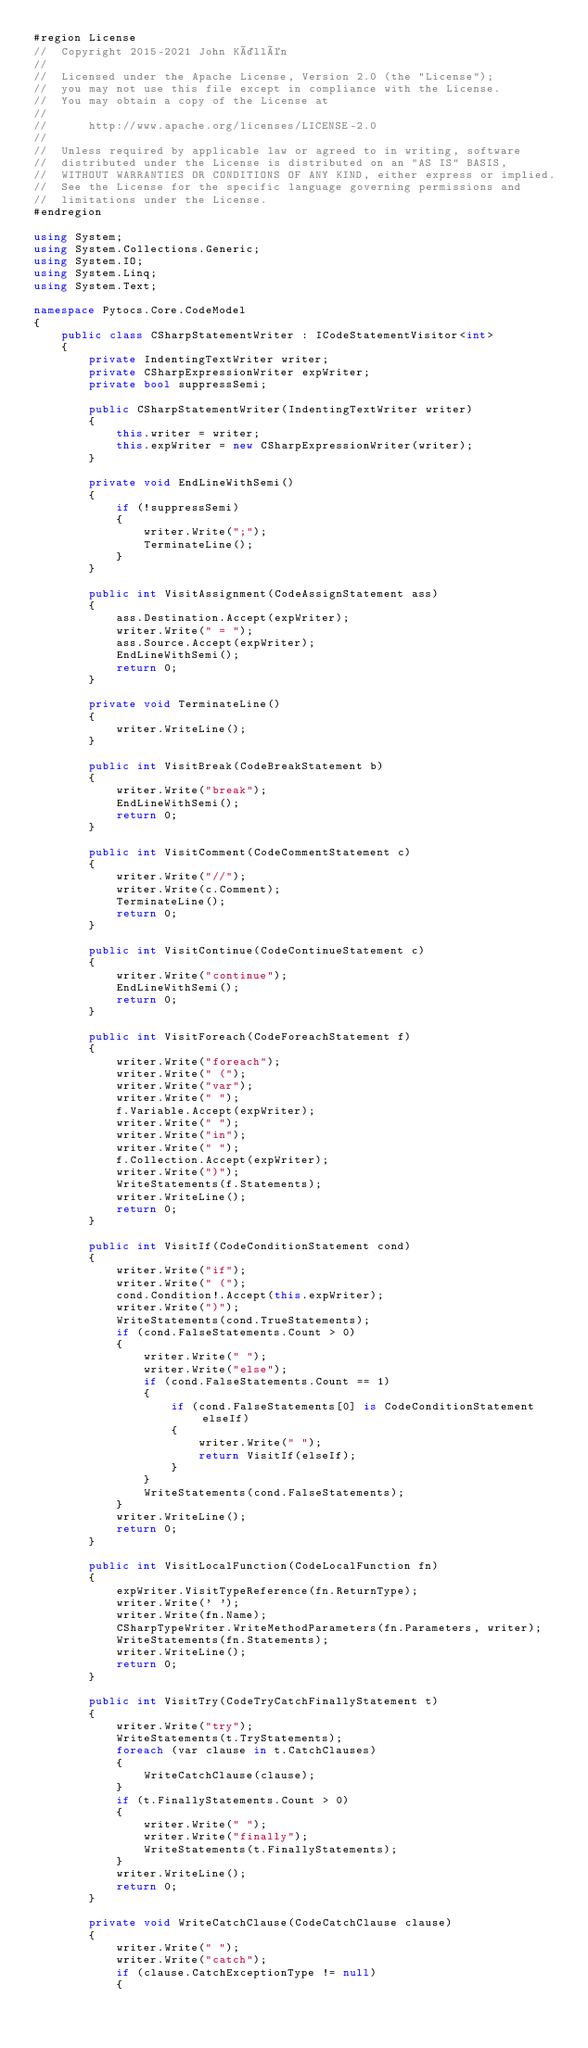Convert code to text. <code><loc_0><loc_0><loc_500><loc_500><_C#_>#region License
//  Copyright 2015-2021 John Källén
// 
//  Licensed under the Apache License, Version 2.0 (the "License");
//  you may not use this file except in compliance with the License.
//  You may obtain a copy of the License at
// 
//      http://www.apache.org/licenses/LICENSE-2.0
// 
//  Unless required by applicable law or agreed to in writing, software
//  distributed under the License is distributed on an "AS IS" BASIS,
//  WITHOUT WARRANTIES OR CONDITIONS OF ANY KIND, either express or implied.
//  See the License for the specific language governing permissions and
//  limitations under the License.
#endregion

using System;
using System.Collections.Generic;
using System.IO;
using System.Linq;
using System.Text;

namespace Pytocs.Core.CodeModel
{
    public class CSharpStatementWriter : ICodeStatementVisitor<int>
    {
        private IndentingTextWriter writer;
        private CSharpExpressionWriter expWriter;
        private bool suppressSemi;

        public CSharpStatementWriter(IndentingTextWriter writer)
        {
            this.writer = writer;
            this.expWriter = new CSharpExpressionWriter(writer);
        }

        private void EndLineWithSemi()
        {
            if (!suppressSemi)
            {
                writer.Write(";");
                TerminateLine();
            }
        }

        public int VisitAssignment(CodeAssignStatement ass)
        {
            ass.Destination.Accept(expWriter);
            writer.Write(" = ");
            ass.Source.Accept(expWriter);
            EndLineWithSemi();
            return 0;
        }

        private void TerminateLine()
        {
            writer.WriteLine();
        }

        public int VisitBreak(CodeBreakStatement b)
        {
            writer.Write("break");
            EndLineWithSemi();
            return 0;
        }

        public int VisitComment(CodeCommentStatement c)
        {
            writer.Write("//");
            writer.Write(c.Comment);
            TerminateLine();
            return 0;
        }

        public int VisitContinue(CodeContinueStatement c)
        {
            writer.Write("continue");
            EndLineWithSemi();
            return 0;
        }

        public int VisitForeach(CodeForeachStatement f)
        {
            writer.Write("foreach");
            writer.Write(" (");
            writer.Write("var");
            writer.Write(" ");
            f.Variable.Accept(expWriter);
            writer.Write(" ");
            writer.Write("in");
            writer.Write(" ");
            f.Collection.Accept(expWriter);
            writer.Write(")");
            WriteStatements(f.Statements);
            writer.WriteLine();
            return 0;
        }

        public int VisitIf(CodeConditionStatement cond)
        {
            writer.Write("if");
            writer.Write(" (");
            cond.Condition!.Accept(this.expWriter);
            writer.Write(")");
            WriteStatements(cond.TrueStatements);
            if (cond.FalseStatements.Count > 0)
            {
                writer.Write(" ");
                writer.Write("else");
                if (cond.FalseStatements.Count == 1)
                {
                    if (cond.FalseStatements[0] is CodeConditionStatement elseIf)
                    {
                        writer.Write(" ");
                        return VisitIf(elseIf);
                    }
                }
                WriteStatements(cond.FalseStatements);
            }
            writer.WriteLine();
            return 0;
        }

        public int VisitLocalFunction(CodeLocalFunction fn)
        { 
            expWriter.VisitTypeReference(fn.ReturnType);
            writer.Write(' ');
            writer.Write(fn.Name);
            CSharpTypeWriter.WriteMethodParameters(fn.Parameters, writer);
            WriteStatements(fn.Statements);
            writer.WriteLine();
            return 0;
        }

        public int VisitTry(CodeTryCatchFinallyStatement t)
        {
            writer.Write("try");
            WriteStatements(t.TryStatements);
            foreach (var clause in t.CatchClauses)
            {
                WriteCatchClause(clause);
            }
            if (t.FinallyStatements.Count > 0)
            {
                writer.Write(" ");
                writer.Write("finally");
                WriteStatements(t.FinallyStatements);
            }
            writer.WriteLine();
            return 0;
        }

        private void WriteCatchClause(CodeCatchClause clause)
        {
            writer.Write(" ");
            writer.Write("catch");
            if (clause.CatchExceptionType != null)
            {</code> 